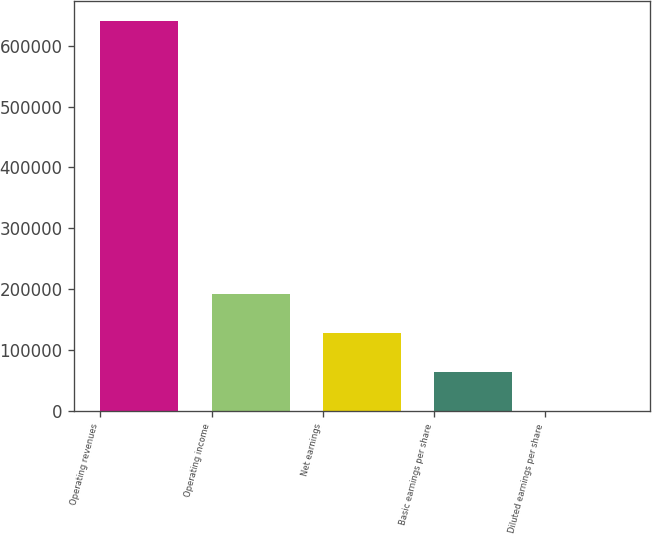Convert chart to OTSL. <chart><loc_0><loc_0><loc_500><loc_500><bar_chart><fcel>Operating revenues<fcel>Operating income<fcel>Net earnings<fcel>Basic earnings per share<fcel>Diluted earnings per share<nl><fcel>640746<fcel>192224<fcel>128149<fcel>64074.9<fcel>0.32<nl></chart> 